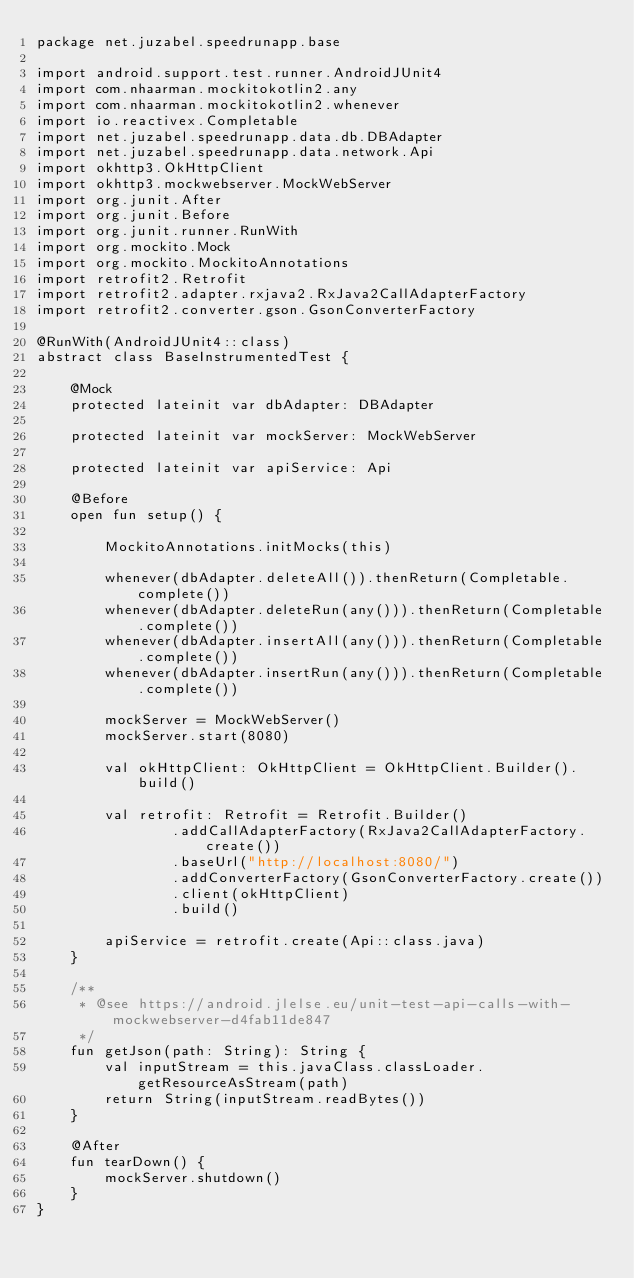Convert code to text. <code><loc_0><loc_0><loc_500><loc_500><_Kotlin_>package net.juzabel.speedrunapp.base

import android.support.test.runner.AndroidJUnit4
import com.nhaarman.mockitokotlin2.any
import com.nhaarman.mockitokotlin2.whenever
import io.reactivex.Completable
import net.juzabel.speedrunapp.data.db.DBAdapter
import net.juzabel.speedrunapp.data.network.Api
import okhttp3.OkHttpClient
import okhttp3.mockwebserver.MockWebServer
import org.junit.After
import org.junit.Before
import org.junit.runner.RunWith
import org.mockito.Mock
import org.mockito.MockitoAnnotations
import retrofit2.Retrofit
import retrofit2.adapter.rxjava2.RxJava2CallAdapterFactory
import retrofit2.converter.gson.GsonConverterFactory

@RunWith(AndroidJUnit4::class)
abstract class BaseInstrumentedTest {

    @Mock
    protected lateinit var dbAdapter: DBAdapter

    protected lateinit var mockServer: MockWebServer

    protected lateinit var apiService: Api

    @Before
    open fun setup() {

        MockitoAnnotations.initMocks(this)

        whenever(dbAdapter.deleteAll()).thenReturn(Completable.complete())
        whenever(dbAdapter.deleteRun(any())).thenReturn(Completable.complete())
        whenever(dbAdapter.insertAll(any())).thenReturn(Completable.complete())
        whenever(dbAdapter.insertRun(any())).thenReturn(Completable.complete())

        mockServer = MockWebServer()
        mockServer.start(8080)

        val okHttpClient: OkHttpClient = OkHttpClient.Builder().build()

        val retrofit: Retrofit = Retrofit.Builder()
                .addCallAdapterFactory(RxJava2CallAdapterFactory.create())
                .baseUrl("http://localhost:8080/")
                .addConverterFactory(GsonConverterFactory.create())
                .client(okHttpClient)
                .build()

        apiService = retrofit.create(Api::class.java)
    }

    /**
     * @see https://android.jlelse.eu/unit-test-api-calls-with-mockwebserver-d4fab11de847
     */
    fun getJson(path: String): String {
        val inputStream = this.javaClass.classLoader.getResourceAsStream(path)
        return String(inputStream.readBytes())
    }

    @After
    fun tearDown() {
        mockServer.shutdown()
    }
}</code> 